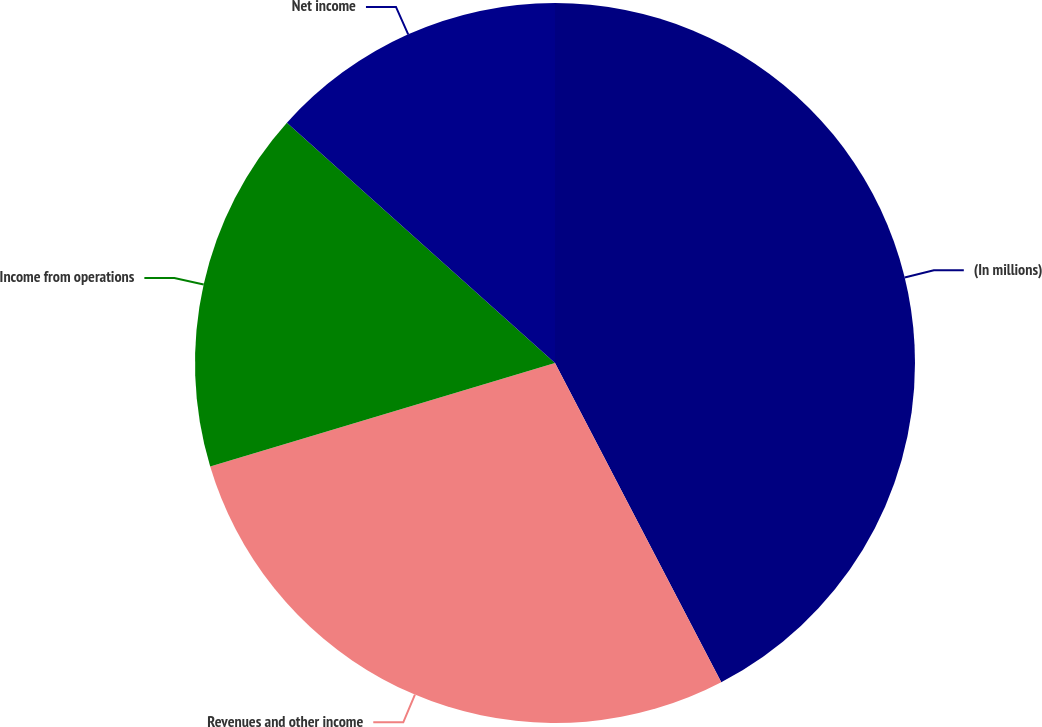Convert chart. <chart><loc_0><loc_0><loc_500><loc_500><pie_chart><fcel>(In millions)<fcel>Revenues and other income<fcel>Income from operations<fcel>Net income<nl><fcel>42.36%<fcel>28.0%<fcel>16.27%<fcel>13.37%<nl></chart> 